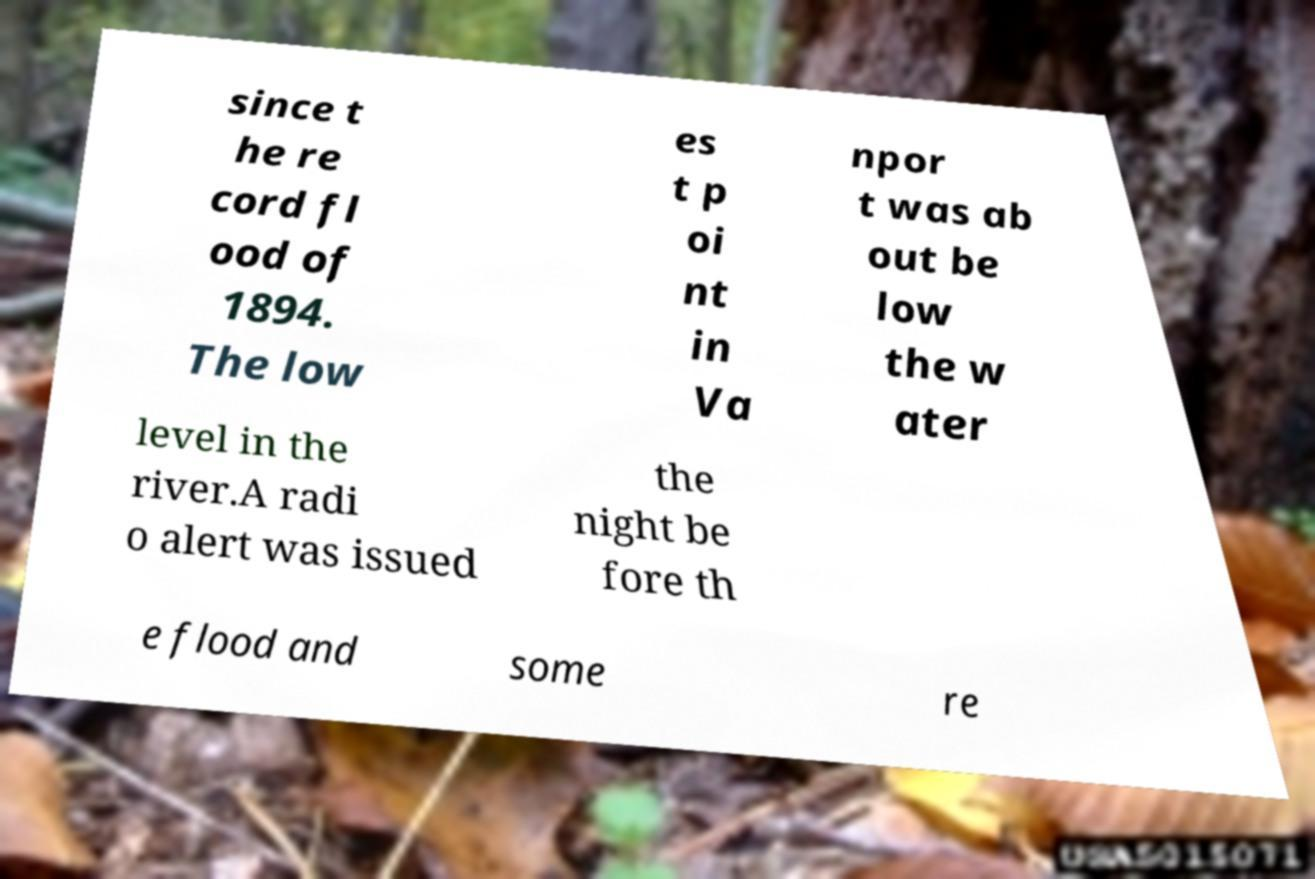For documentation purposes, I need the text within this image transcribed. Could you provide that? since t he re cord fl ood of 1894. The low es t p oi nt in Va npor t was ab out be low the w ater level in the river.A radi o alert was issued the night be fore th e flood and some re 